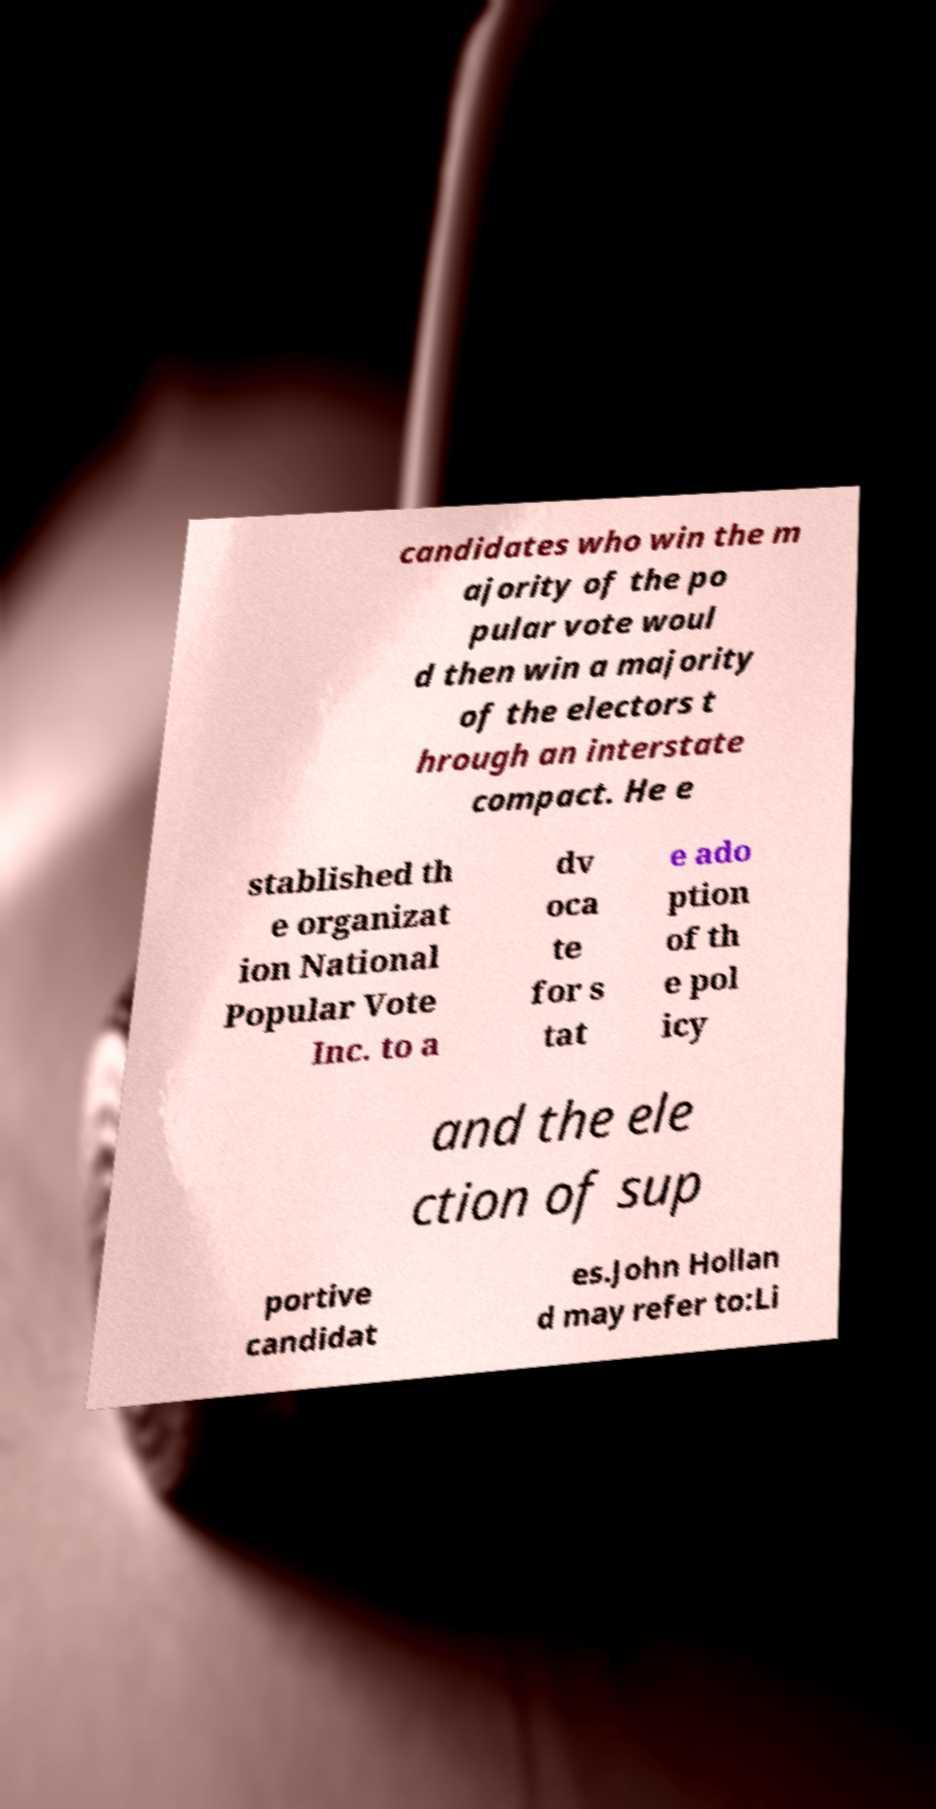Please read and relay the text visible in this image. What does it say? candidates who win the m ajority of the po pular vote woul d then win a majority of the electors t hrough an interstate compact. He e stablished th e organizat ion National Popular Vote Inc. to a dv oca te for s tat e ado ption of th e pol icy and the ele ction of sup portive candidat es.John Hollan d may refer to:Li 